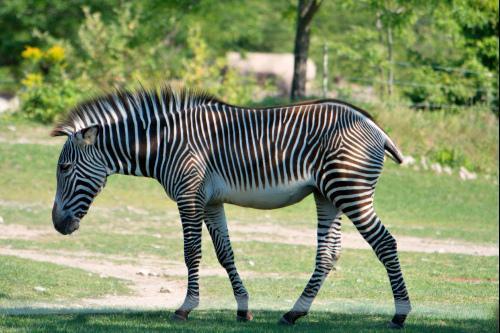How many people are in the photo?
Give a very brief answer. 0. 